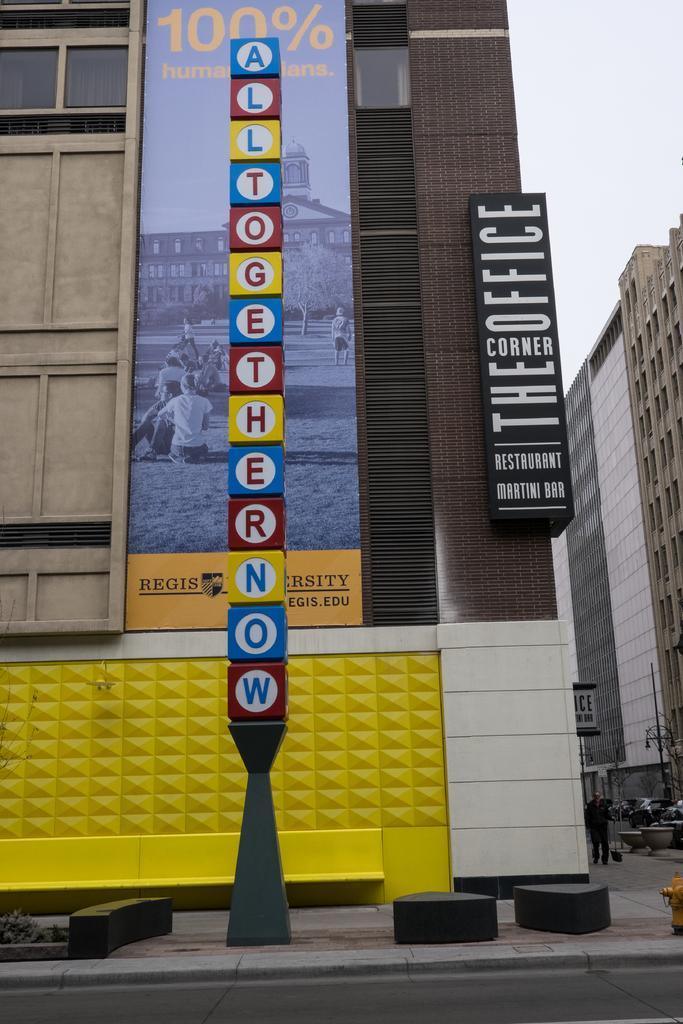In one or two sentences, can you explain what this image depicts? In the middle of the image there is a pole. Behind the pole there are some buildings and banners. At the bottom of the image there is road and there are some plants. In the bottom right corner of the image a man is holding a bag and walking. Behind him there are some vehicles. In the top right corner of the image there is sky. 